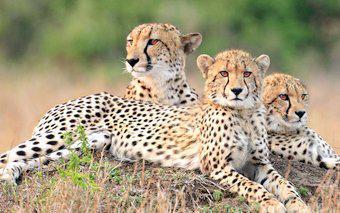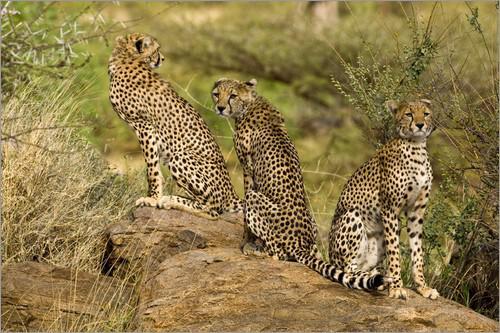The first image is the image on the left, the second image is the image on the right. Considering the images on both sides, is "in the left image cheetahs are laying on a mound of dirt" valid? Answer yes or no. Yes. The first image is the image on the left, the second image is the image on the right. Evaluate the accuracy of this statement regarding the images: "In one image, there are three cheetahs sitting on their haunches, and in the other image, there are at least three cheetahs lying down.". Is it true? Answer yes or no. Yes. 